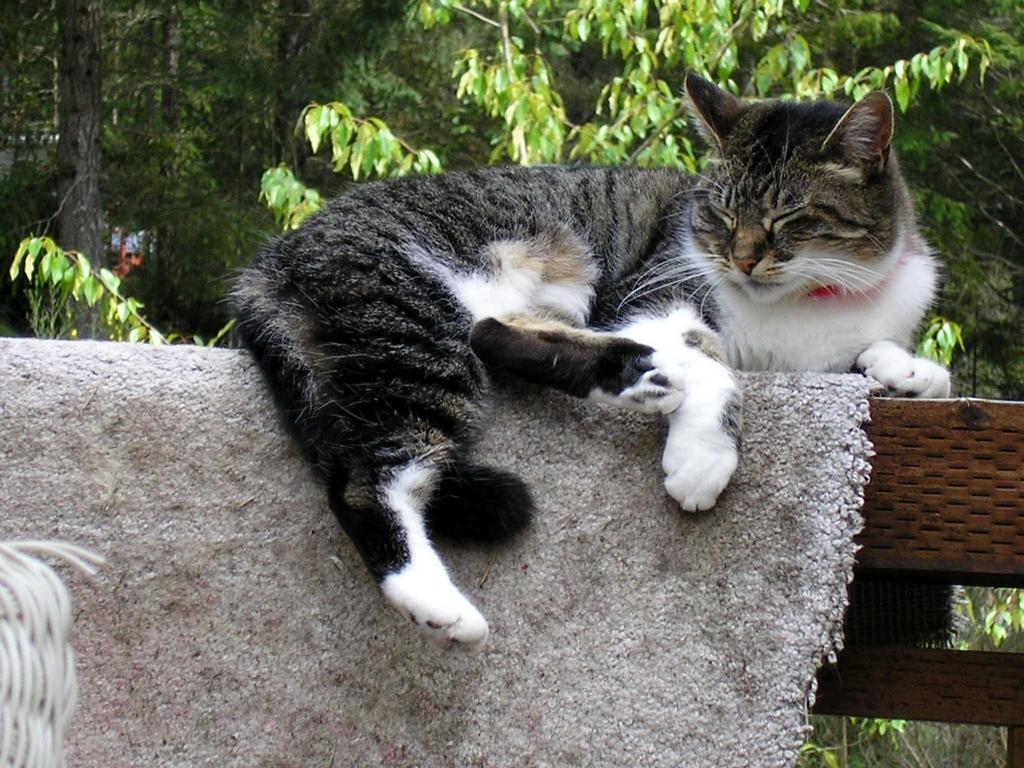How would you summarize this image in a sentence or two? In this picture we can see a cat laying here, there is a mat here, in the background there are some trees. 